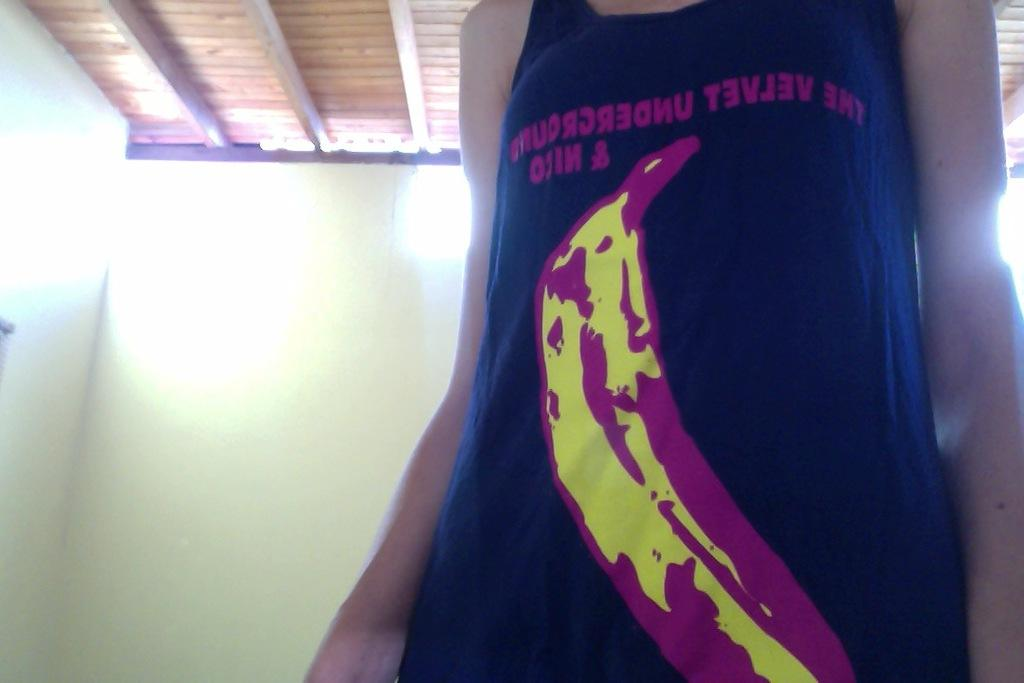<image>
Describe the image concisely. A woman wears a blue shirt with "The Velvet Underground" on the front in reversed letters/ 